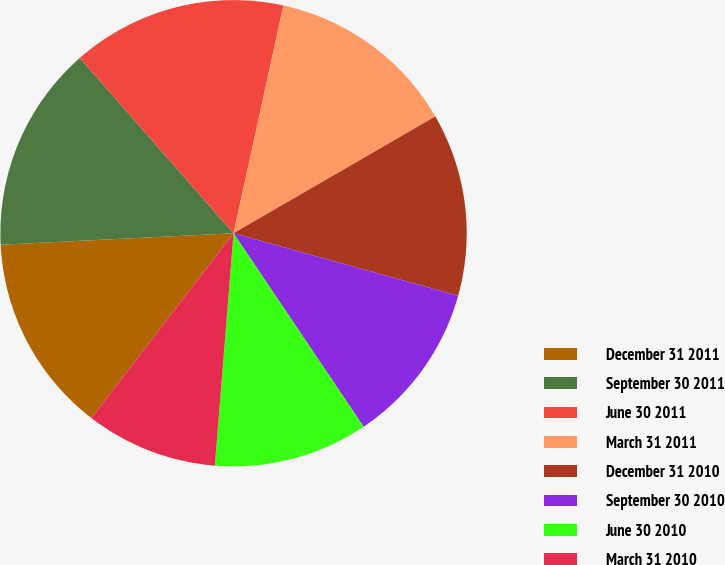Convert chart to OTSL. <chart><loc_0><loc_0><loc_500><loc_500><pie_chart><fcel>December 31 2011<fcel>September 30 2011<fcel>June 30 2011<fcel>March 31 2011<fcel>December 31 2010<fcel>September 30 2010<fcel>June 30 2010<fcel>March 31 2010<nl><fcel>13.78%<fcel>14.33%<fcel>14.89%<fcel>13.22%<fcel>12.67%<fcel>11.26%<fcel>10.7%<fcel>9.16%<nl></chart> 